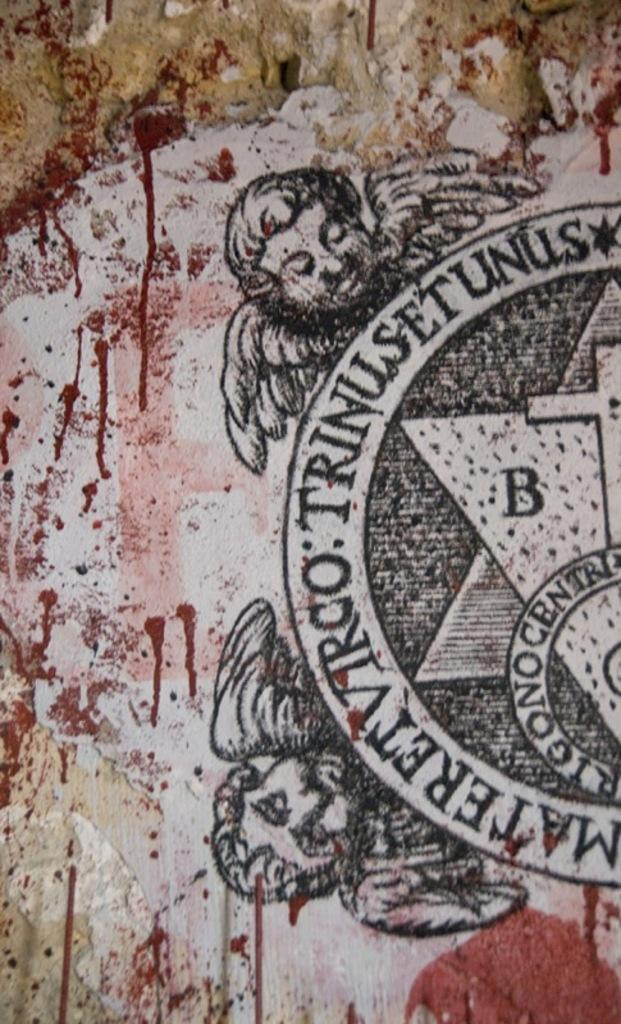What is the main subject of the image? There is a painting in the image. What is depicted in the painting? The painting depicts two persons with wings. What else can be seen in the image besides the painting? There is a symbol with text on it to the right side of the image. Can you tell me how many islands are visible in the painting? There are no islands depicted in the painting; it features two persons with wings. What type of club is shown being used by the persons in the painting? There is no club present in the painting; it depicts two persons with wings. 